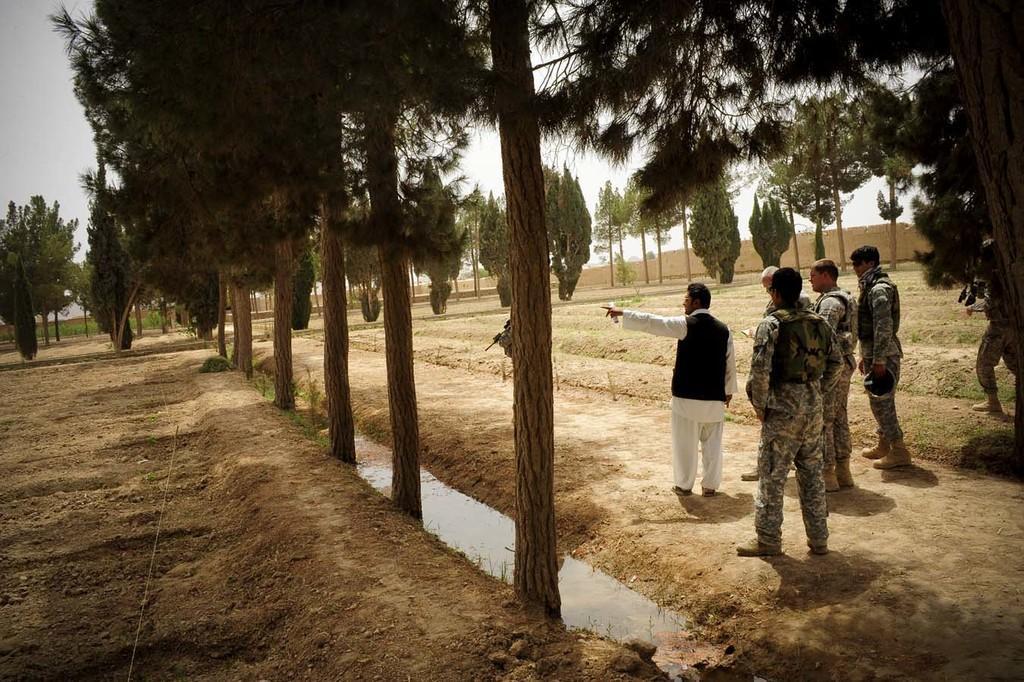Could you give a brief overview of what you see in this image? In this picture I can see group of people standing, there are trees, and in the background there is sky. 